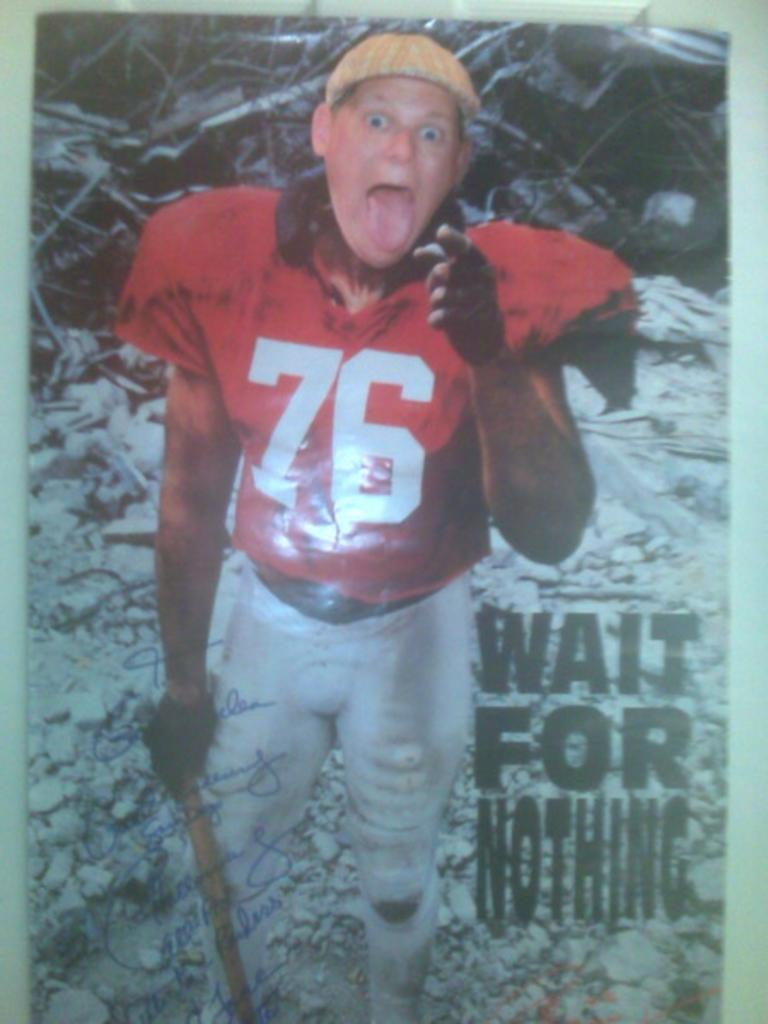Provide a one-sentence caption for the provided image. A poster of football player number 76 with the caption, "Wait for Nothing". 